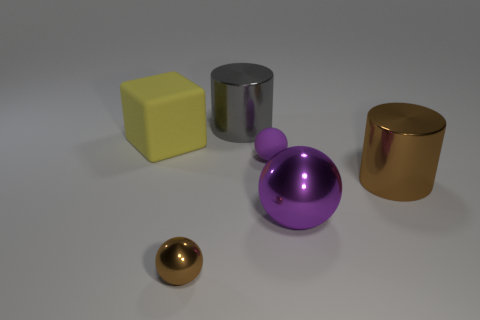There is a metallic ball that is behind the brown object left of the gray cylinder; what is its size?
Provide a succinct answer. Large. Is there a shiny object?
Your answer should be very brief. Yes. There is a big thing that is on the left side of the big purple metallic thing and in front of the gray metal thing; what material is it?
Offer a very short reply. Rubber. Is the number of metal cylinders that are on the left side of the tiny purple ball greater than the number of gray cylinders that are in front of the gray shiny cylinder?
Your answer should be very brief. Yes. Is there another yellow block that has the same size as the yellow cube?
Offer a very short reply. No. What is the size of the shiny sphere left of the purple sphere in front of the cylinder that is in front of the large rubber block?
Make the answer very short. Small. What color is the small metal ball?
Provide a short and direct response. Brown. Are there more matte blocks in front of the gray metal cylinder than small red metal things?
Provide a succinct answer. Yes. What number of large objects are right of the yellow thing?
Your response must be concise. 3. The thing that is the same color as the tiny rubber sphere is what shape?
Keep it short and to the point. Sphere. 